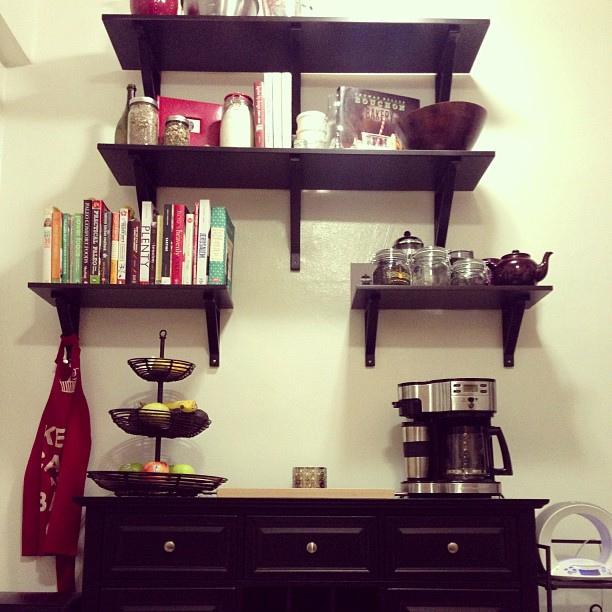Can you eat the items in the stand?
Give a very brief answer. Yes. How many books are on the shelf?
Be succinct. 20. What is the red item hanging on the left under the books?
Quick response, please. Apron. 